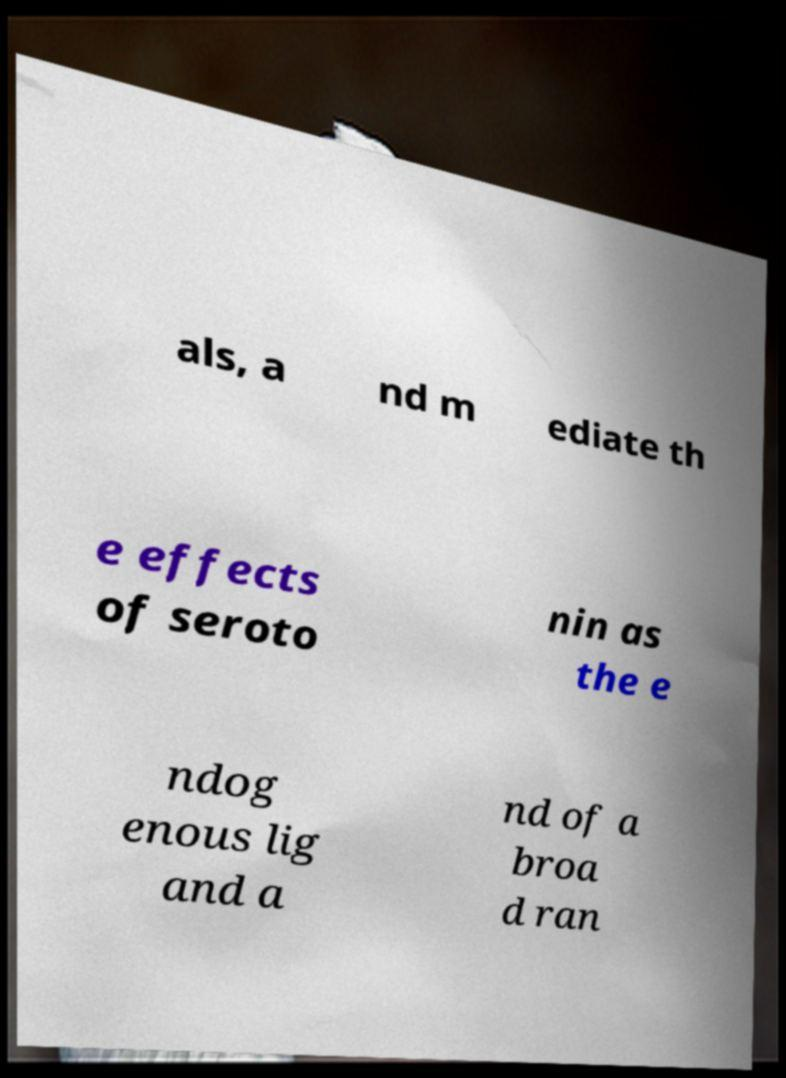What messages or text are displayed in this image? I need them in a readable, typed format. als, a nd m ediate th e effects of seroto nin as the e ndog enous lig and a nd of a broa d ran 